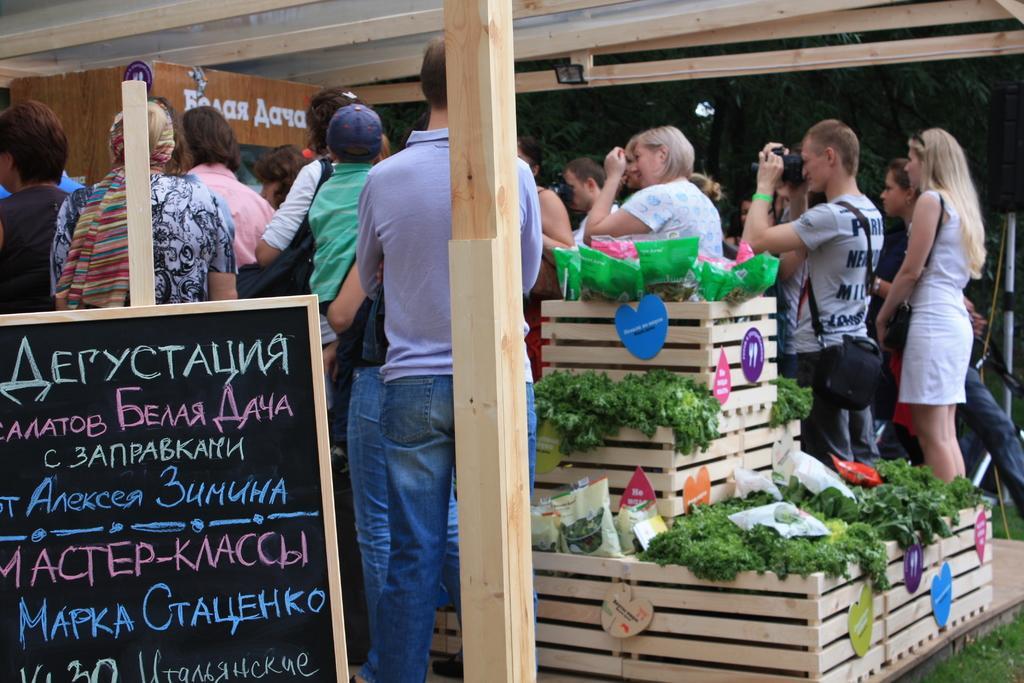Describe this image in one or two sentences. This image consists of many people. On the left, there is a board. In the middle, we can see a potted plant made up of wood. At the bottom, there is grass. At the top, there is a roof. 